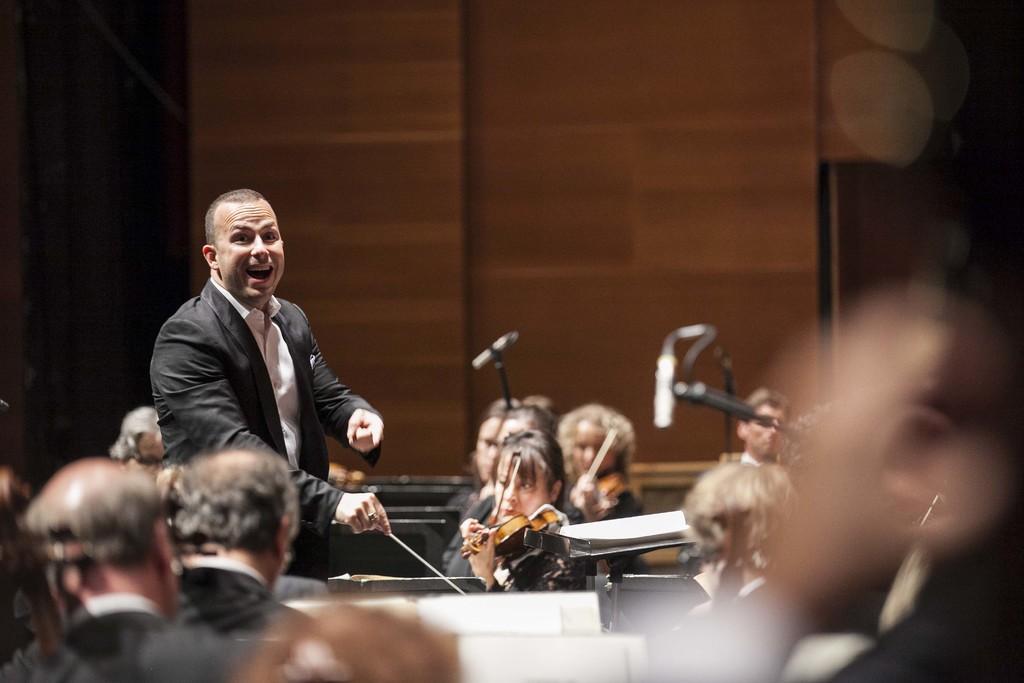How would you summarize this image in a sentence or two? This picture seems to be clicked inside the hall. In the foreground we can see the group of persons and some other objects. On the left we can see a person wearing suit, holding stick and standing. On the right we can see the group of persons sitting and seems to be playing musical instruments and we can see the wall in the background and we can see some other objects and the microphones. 